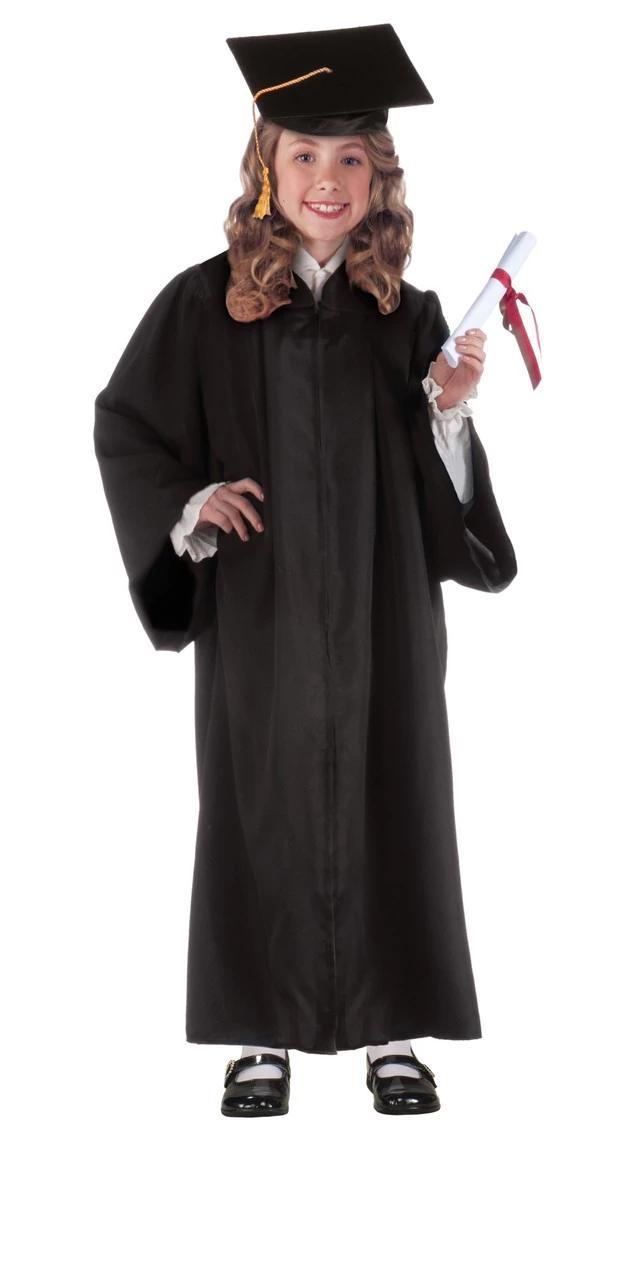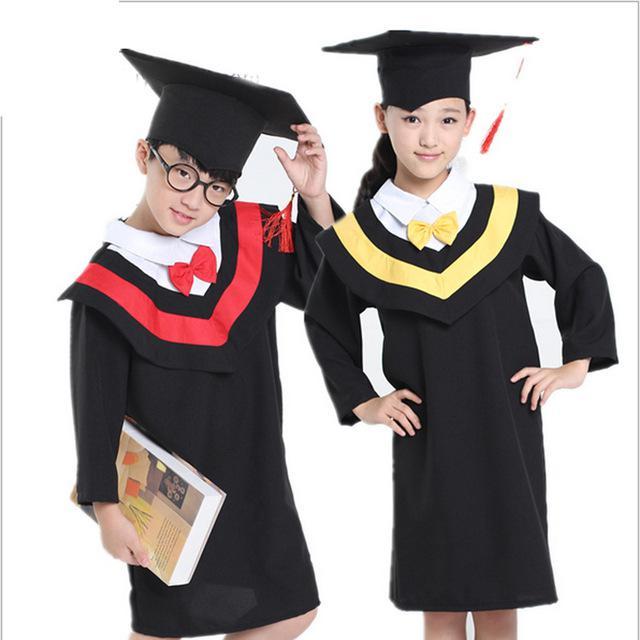The first image is the image on the left, the second image is the image on the right. For the images shown, is this caption "In one of the images there are a pair of students wearing a graduation cap and gown." true? Answer yes or no. Yes. 